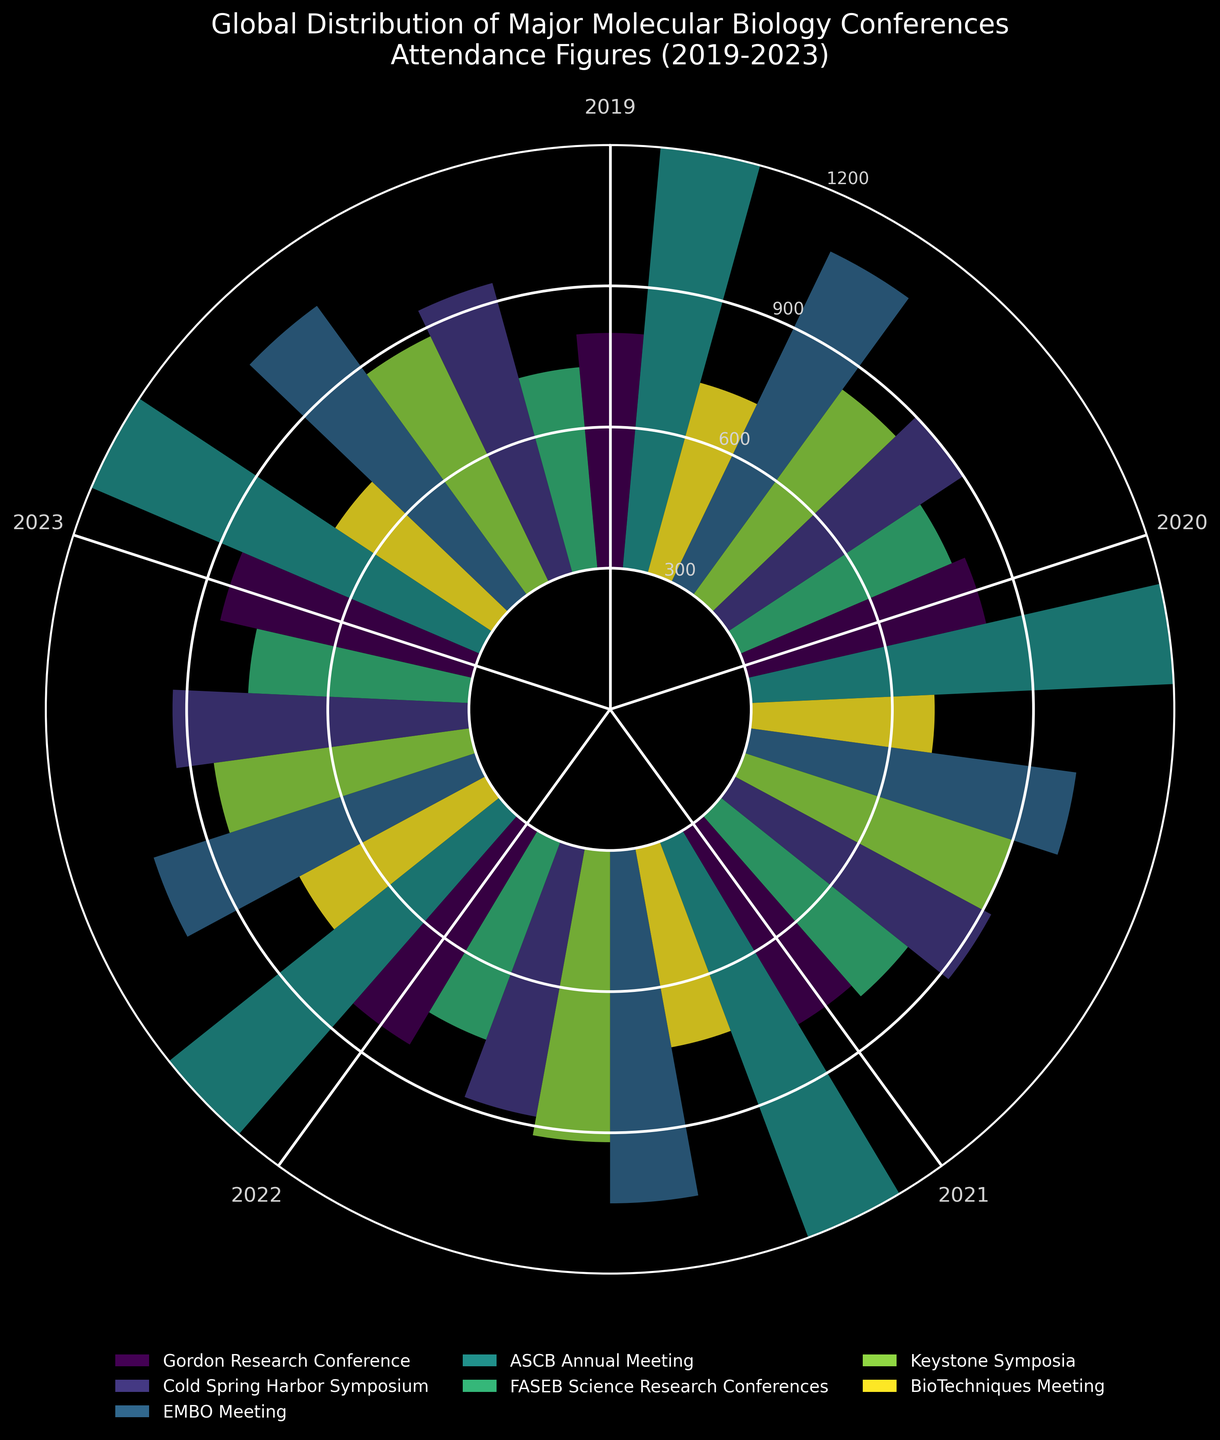What's the title of the figure? The title of the chart is located at the top and usually explains the purpose or content of the chart explicitly
Answer: "Global Distribution of Major Molecular Biology Conferences Attendance Figures (2019-2023)" How many years of attendance data are shown in the figure? The years are indicated along the radial axis, with each data point corresponding to a specific year from 2019 to 2023
Answer: 5 years Which conference had the highest attendance in 2023? By visually identifying the largest radius in the 2023 segment of the polar area chart, you can determine which conference had the highest attendance
Answer: ASCB Annual Meeting What is the range of attendance numbers shown on the radial axis? The radial axis values, as shown by the ticks and labels, provide the range of attendance figures used in the chart
Answer: 300 to 1200 How did the attendance for the Keystone Symposia change from 2019 to 2023? Observing the radial distance of the bars associated with Keystone Symposia from 2019 to 2023 provides insight into the change in attendance
Answer: Increased Which conference showed the most significant fluctuation in attendance over the years? By comparing the variation in the lengths of the bars across different years for each conference, we can identify the conference with the most significant attendance fluctuation
Answer: FASEB Science Research Conferences Is there any year where all conferences had an increase in attendance compared to the previous year? Check if for any particular year, all conference bars are taller than their previous year's corresponding bar
Answer: 2020 How does the attendance of the EMBO Meeting in 2021 compare to the ASCB Annual Meeting in the same year? Look at the respective bars for EMBO Meeting and ASCB Annual Meeting in the 2021 segment to directly compare their heights
Answer: The ASCB Annual Meeting had higher attendance Which conference consistently had the lowest attendance figures over the five years? Identify the conference with consistently shorter bars across all years, indicating lower attendance
Answer: BioTechniques Meeting What is the overall trend for the Cold Spring Harbor Symposium attendance from 2019 to 2023? By examining the sequence of bars for the Cold Spring Harbor Symposium from 2019 to 2023, we can note the general trend in their heights
Answer: Increasing 